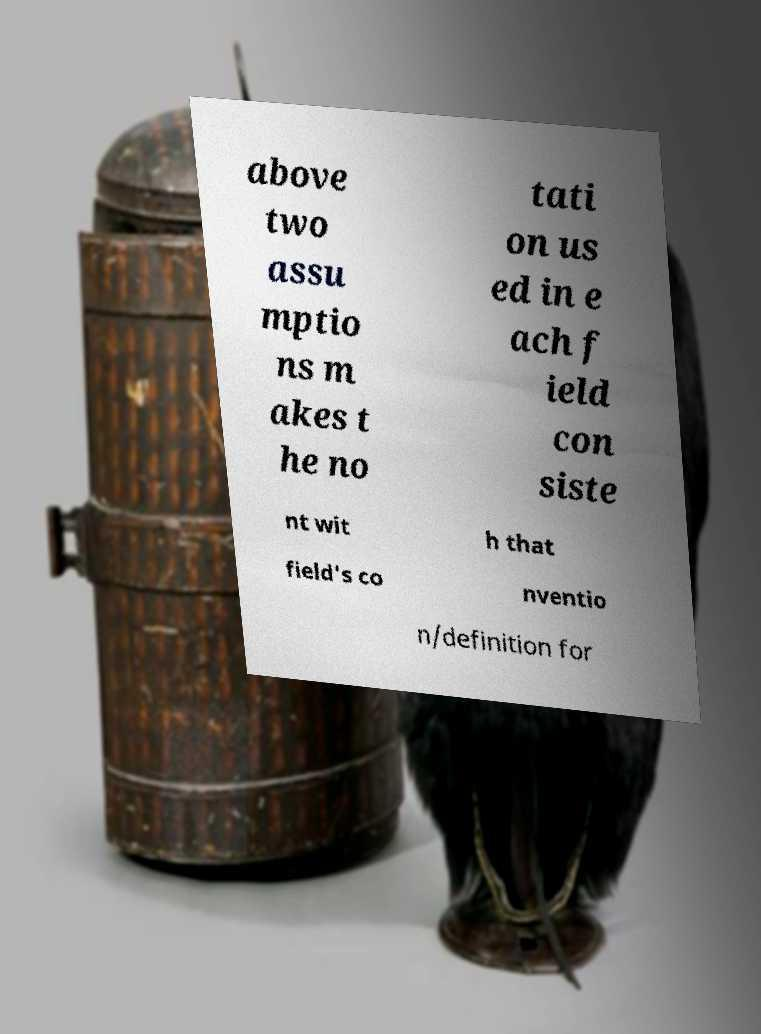Could you assist in decoding the text presented in this image and type it out clearly? above two assu mptio ns m akes t he no tati on us ed in e ach f ield con siste nt wit h that field's co nventio n/definition for 